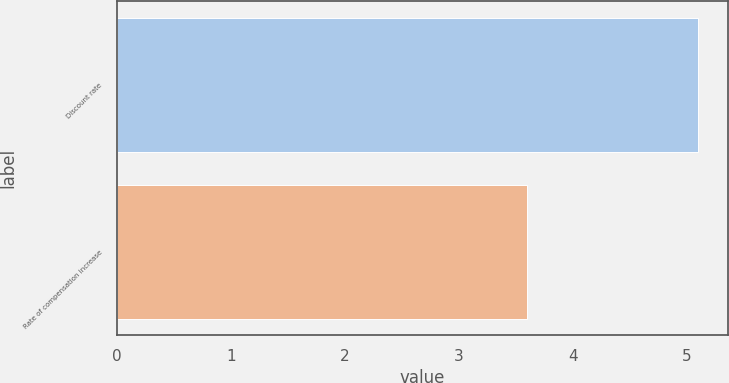<chart> <loc_0><loc_0><loc_500><loc_500><bar_chart><fcel>Discount rate<fcel>Rate of compensation increase<nl><fcel>5.1<fcel>3.6<nl></chart> 